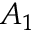Convert formula to latex. <formula><loc_0><loc_0><loc_500><loc_500>A _ { 1 }</formula> 